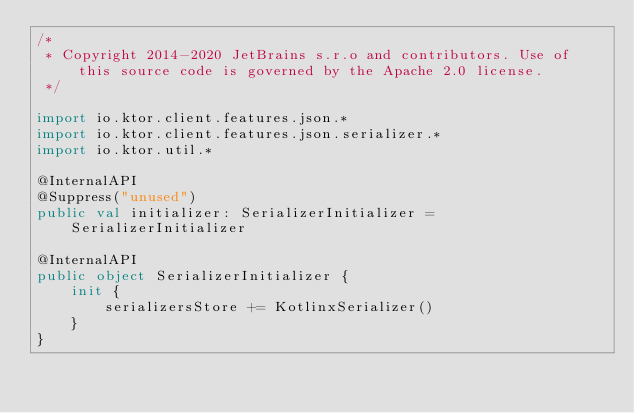Convert code to text. <code><loc_0><loc_0><loc_500><loc_500><_Kotlin_>/*
 * Copyright 2014-2020 JetBrains s.r.o and contributors. Use of this source code is governed by the Apache 2.0 license.
 */

import io.ktor.client.features.json.*
import io.ktor.client.features.json.serializer.*
import io.ktor.util.*

@InternalAPI
@Suppress("unused")
public val initializer: SerializerInitializer = SerializerInitializer

@InternalAPI
public object SerializerInitializer {
    init {
        serializersStore += KotlinxSerializer()
    }
}
</code> 